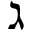<formula> <loc_0><loc_0><loc_500><loc_500>\gimel</formula> 